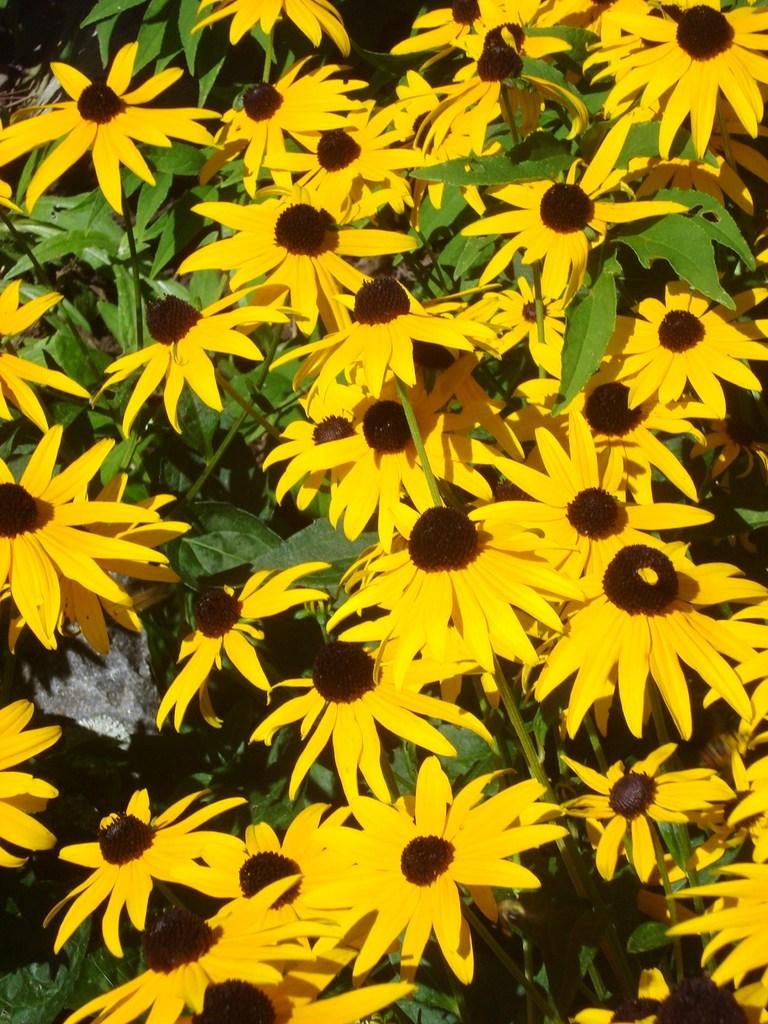What type of living organisms can be seen in the image? There are flowers in the image. What colors are the flowers in the image? The flowers are yellow and brown in color. What other part of the plant is visible in the image? There are green leaves in the image. What type of crook can be seen holding the flowers in the image? There is no crook present in the image; the flowers are likely growing in a garden or pot. What type of skin is visible on the flowers in the image? Flowers do not have skin, as they are plants and not animals. 